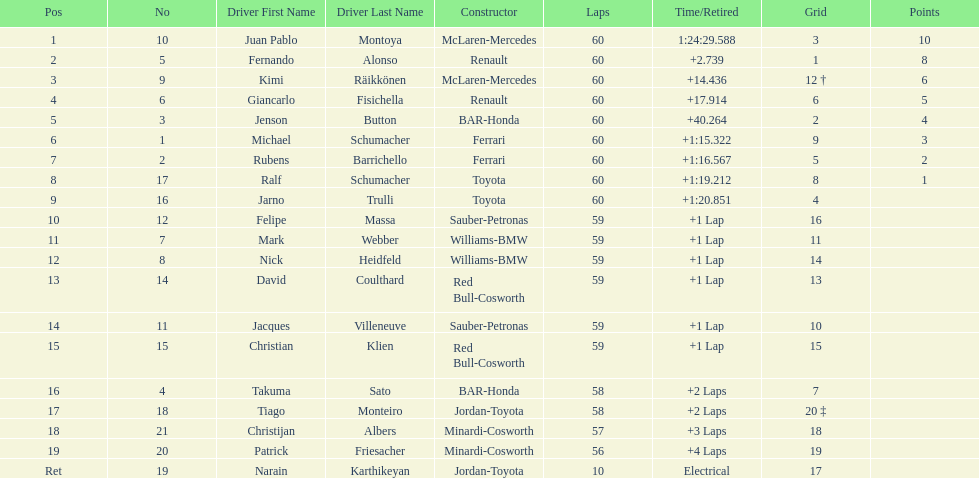After 8th position, how many points does a driver receive? 0. 